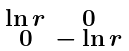Convert formula to latex. <formula><loc_0><loc_0><loc_500><loc_500>\begin{smallmatrix} \ln r & 0 \\ 0 & - \ln r \end{smallmatrix}</formula> 